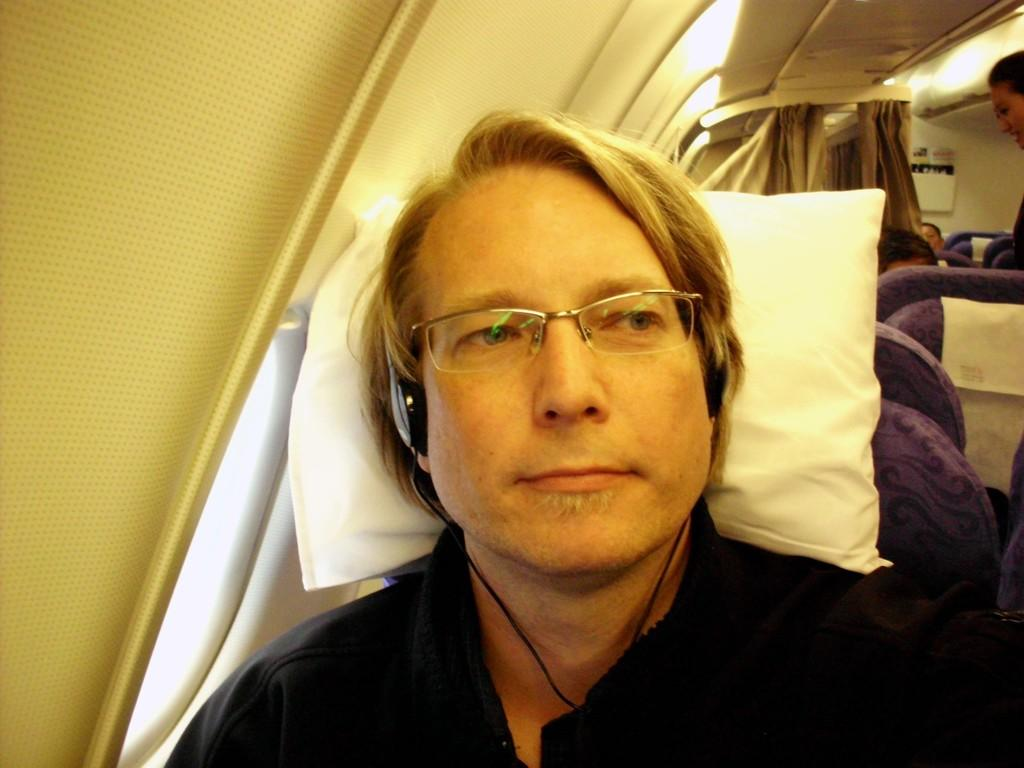Who or what is present in the image? There is a person in the image. What can be observed about the person's appearance? The person is wearing spectacles. What is the person's position in the image? The person is sitting on a seat. Can you describe the location of the seat in relation to other elements in the image? The seat is beside a window. What type of glue is being used by the person in the image? There is no glue present in the image; the person is wearing spectacles and sitting on a seat beside a window. 